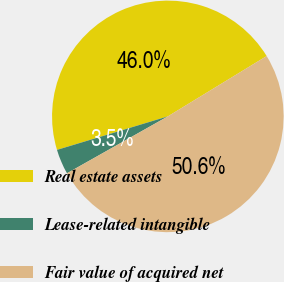<chart> <loc_0><loc_0><loc_500><loc_500><pie_chart><fcel>Real estate assets<fcel>Lease-related intangible<fcel>Fair value of acquired net<nl><fcel>45.95%<fcel>3.5%<fcel>50.55%<nl></chart> 